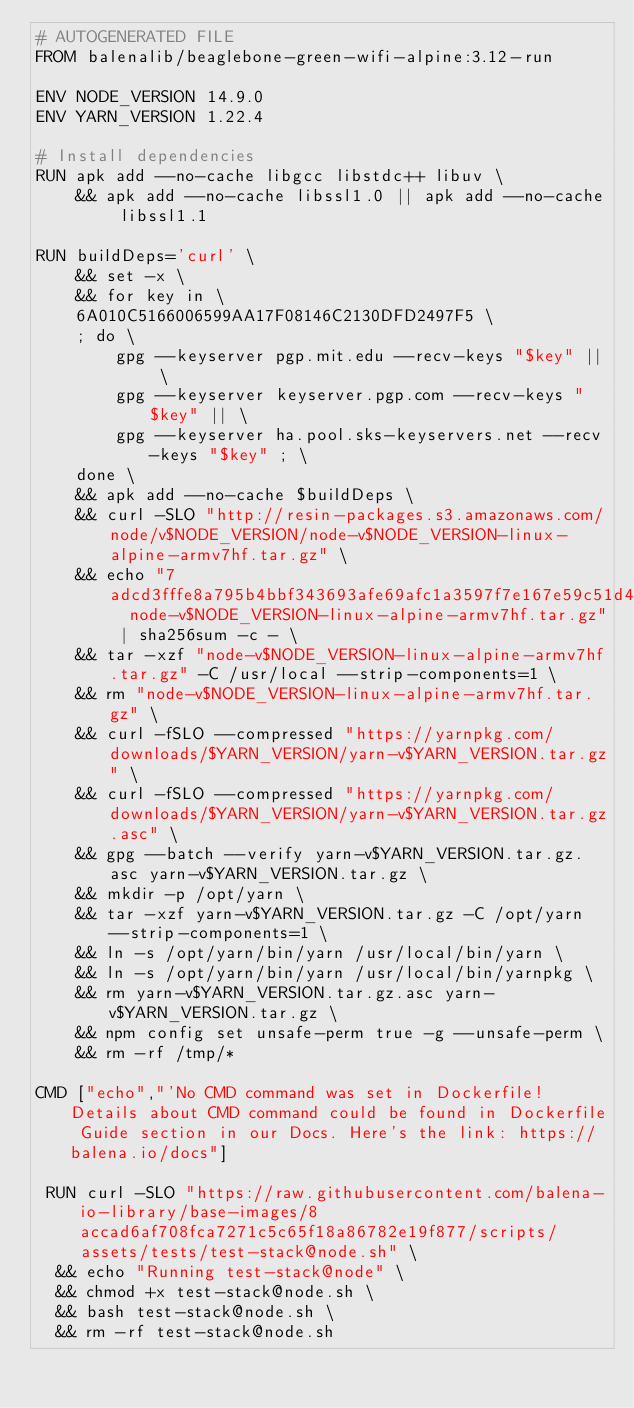Convert code to text. <code><loc_0><loc_0><loc_500><loc_500><_Dockerfile_># AUTOGENERATED FILE
FROM balenalib/beaglebone-green-wifi-alpine:3.12-run

ENV NODE_VERSION 14.9.0
ENV YARN_VERSION 1.22.4

# Install dependencies
RUN apk add --no-cache libgcc libstdc++ libuv \
	&& apk add --no-cache libssl1.0 || apk add --no-cache libssl1.1

RUN buildDeps='curl' \
	&& set -x \
	&& for key in \
	6A010C5166006599AA17F08146C2130DFD2497F5 \
	; do \
		gpg --keyserver pgp.mit.edu --recv-keys "$key" || \
		gpg --keyserver keyserver.pgp.com --recv-keys "$key" || \
		gpg --keyserver ha.pool.sks-keyservers.net --recv-keys "$key" ; \
	done \
	&& apk add --no-cache $buildDeps \
	&& curl -SLO "http://resin-packages.s3.amazonaws.com/node/v$NODE_VERSION/node-v$NODE_VERSION-linux-alpine-armv7hf.tar.gz" \
	&& echo "7adcd3fffe8a795b4bbf343693afe69afc1a3597f7e167e59c51d41d672056af  node-v$NODE_VERSION-linux-alpine-armv7hf.tar.gz" | sha256sum -c - \
	&& tar -xzf "node-v$NODE_VERSION-linux-alpine-armv7hf.tar.gz" -C /usr/local --strip-components=1 \
	&& rm "node-v$NODE_VERSION-linux-alpine-armv7hf.tar.gz" \
	&& curl -fSLO --compressed "https://yarnpkg.com/downloads/$YARN_VERSION/yarn-v$YARN_VERSION.tar.gz" \
	&& curl -fSLO --compressed "https://yarnpkg.com/downloads/$YARN_VERSION/yarn-v$YARN_VERSION.tar.gz.asc" \
	&& gpg --batch --verify yarn-v$YARN_VERSION.tar.gz.asc yarn-v$YARN_VERSION.tar.gz \
	&& mkdir -p /opt/yarn \
	&& tar -xzf yarn-v$YARN_VERSION.tar.gz -C /opt/yarn --strip-components=1 \
	&& ln -s /opt/yarn/bin/yarn /usr/local/bin/yarn \
	&& ln -s /opt/yarn/bin/yarn /usr/local/bin/yarnpkg \
	&& rm yarn-v$YARN_VERSION.tar.gz.asc yarn-v$YARN_VERSION.tar.gz \
	&& npm config set unsafe-perm true -g --unsafe-perm \
	&& rm -rf /tmp/*

CMD ["echo","'No CMD command was set in Dockerfile! Details about CMD command could be found in Dockerfile Guide section in our Docs. Here's the link: https://balena.io/docs"]

 RUN curl -SLO "https://raw.githubusercontent.com/balena-io-library/base-images/8accad6af708fca7271c5c65f18a86782e19f877/scripts/assets/tests/test-stack@node.sh" \
  && echo "Running test-stack@node" \
  && chmod +x test-stack@node.sh \
  && bash test-stack@node.sh \
  && rm -rf test-stack@node.sh 
</code> 